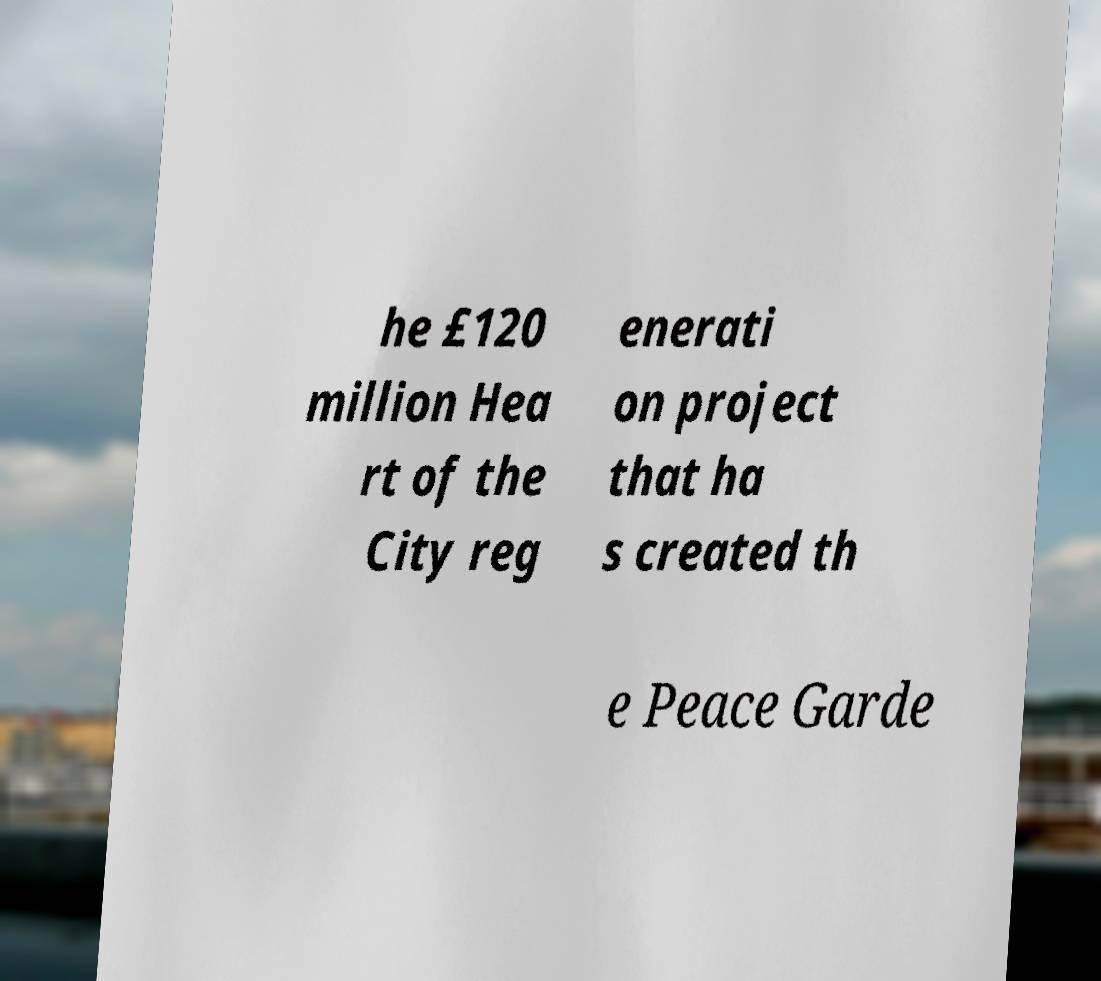Please identify and transcribe the text found in this image. he £120 million Hea rt of the City reg enerati on project that ha s created th e Peace Garde 